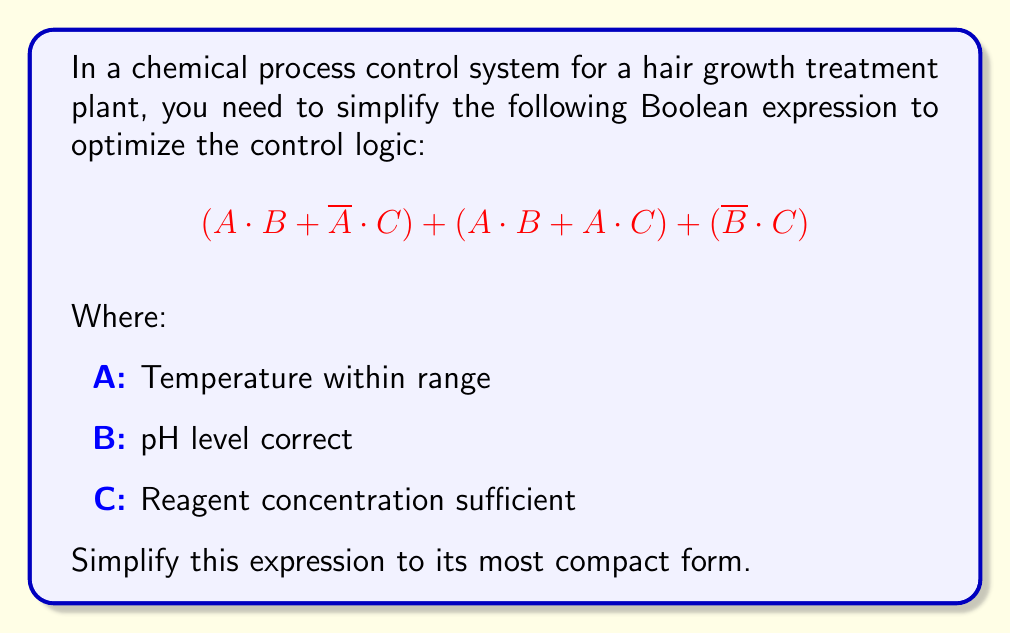Solve this math problem. Let's simplify this Boolean expression step-by-step:

1) First, let's distribute A over (B + C) in the second term:
   $$(A \cdot B + \overline{A} \cdot C) + (A \cdot B + A \cdot C) + (\overline{B} \cdot C)$$
   $$= (A \cdot B + \overline{A} \cdot C) + A \cdot (B + C) + (\overline{B} \cdot C)$$

2) Now, we can use the distributive property to combine the first two terms:
   $$= (A \cdot B + A \cdot C + \overline{A} \cdot C) + (\overline{B} \cdot C)$$

3) In the first parenthesis, we can factor out C:
   $$= (A \cdot B + C \cdot (A + \overline{A})) + (\overline{B} \cdot C)$$

4) We know that $(A + \overline{A}) = 1$ (law of excluded middle), so:
   $$= (A \cdot B + C) + (\overline{B} \cdot C)$$

5) Now, we can distribute C over $(1 + \overline{B})$:
   $$= (A \cdot B + C \cdot (1 + \overline{B}))$$

6) We know that $(1 + \overline{B}) = 1$ (as anything OR 1 is 1), so:
   $$= A \cdot B + C$$

This is the most simplified form of the expression.
Answer: $A \cdot B + C$ 